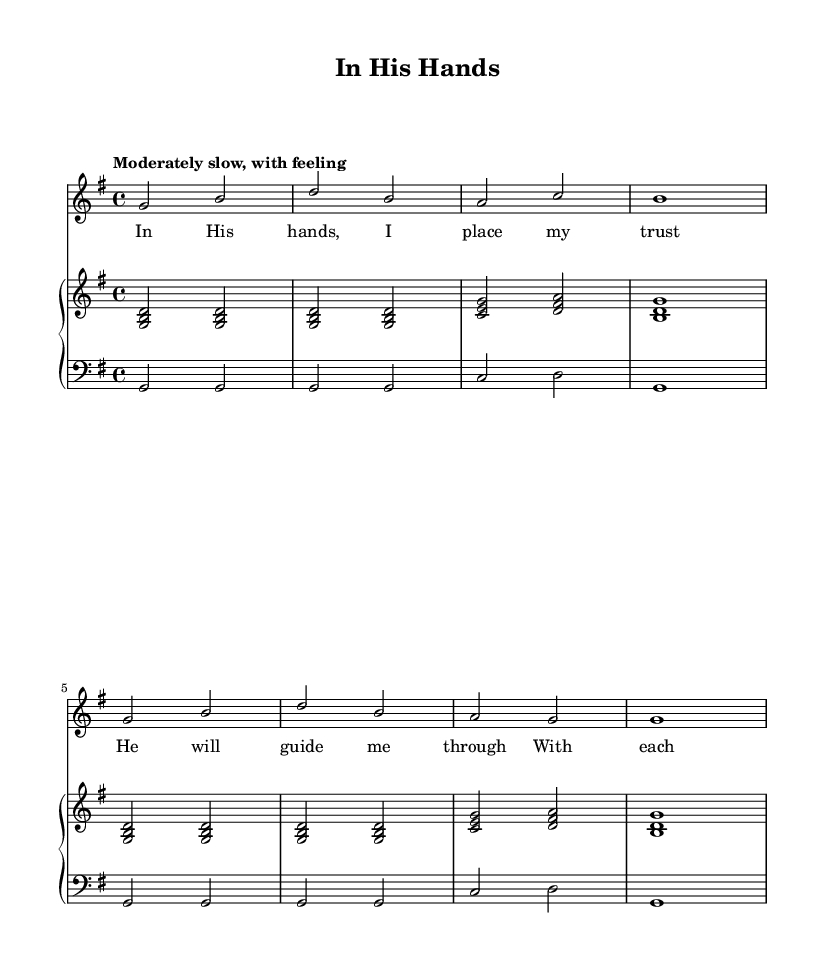What is the key signature of this music? The key signature is indicated by the number of sharps or flats at the beginning of the staff. In this case, since there are no sharps or flats shown, it indicates that the piece is in G major, which has one sharp.
Answer: G major What is the time signature of this music? The time signature is found at the beginning of the score, consisting of two numbers stacked vertically. Here, the time signature is 4/4, meaning there are four beats in a measure and a quarter note receives one beat.
Answer: 4/4 What is the tempo marking of this music? The tempo is indicated in the score with a verbal description at the start, which provides the intended speed. The text "Moderately slow, with feeling" specifies how the piece should be played.
Answer: Moderately slow How many verses does the song appear to have based on the lyrics? The lyrics provided accompany the melody and suggest a single stanza or verse structure. There are four lines in the lyrics, indicating a single verse.
Answer: One verse What is the primary theme expressed in the lyrics? By reading the lyrics, they convey a sense of trust and reliance on a higher power, highlighting faith and guidance. This central message represents the theme of the hymn.
Answer: Trust in a higher power What do the repeated notes in the melody suggest about the musical structure? The repeated notes in the melody indicate a possible emphasis or importance on the key phrases of the lyrics, reflecting a common structure in hymns to reinforce themes, creating a sense of stability and reassurance.
Answer: Emphasis on key phrases 